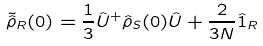Convert formula to latex. <formula><loc_0><loc_0><loc_500><loc_500>\tilde { \hat { \rho } } _ { R } ( 0 ) = \frac { 1 } { 3 } \hat { U } ^ { + } \hat { \rho } _ { S } ( 0 ) \hat { U } + \frac { 2 } { 3 N } \hat { 1 } _ { R }</formula> 